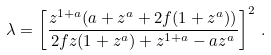Convert formula to latex. <formula><loc_0><loc_0><loc_500><loc_500>\lambda = \left [ \frac { z ^ { 1 + a } ( a + z ^ { a } + 2 f ( 1 + z ^ { a } ) ) } { 2 f z ( 1 + z ^ { a } ) + z ^ { 1 + a } - a z ^ { a } } \right ] ^ { 2 } \, .</formula> 